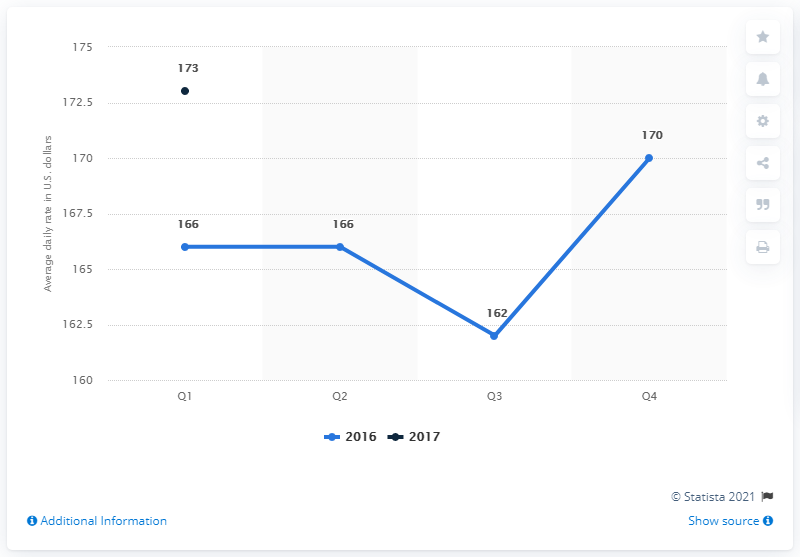Give some essential details in this illustration. The average daily rate of hotels in Charlotte in the first quarter of 2017 was $173. 